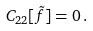Convert formula to latex. <formula><loc_0><loc_0><loc_500><loc_500>C _ { 2 2 } [ \tilde { f } ] = 0 \, .</formula> 